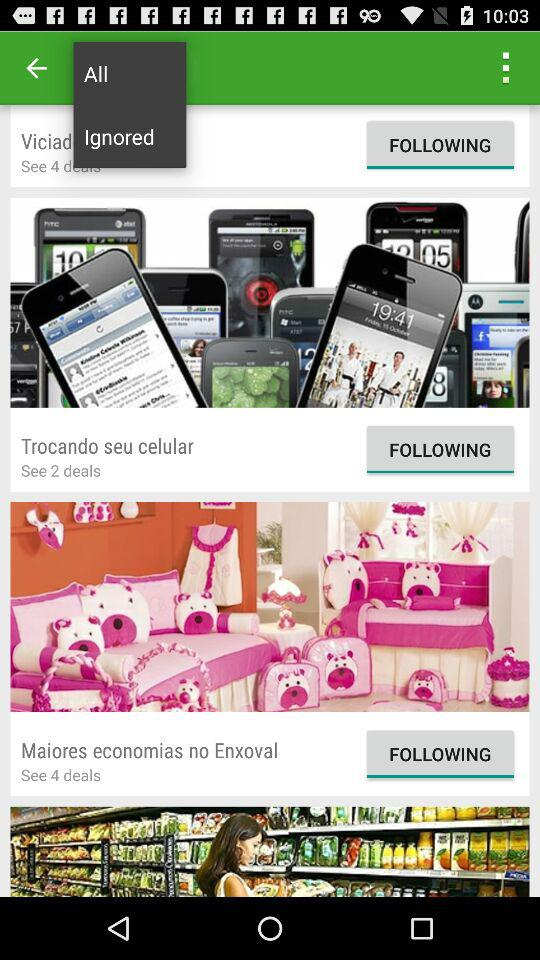Is Maiores economias no Enxoval following or unfollowing?
When the provided information is insufficient, respond with <no answer>. <no answer> 